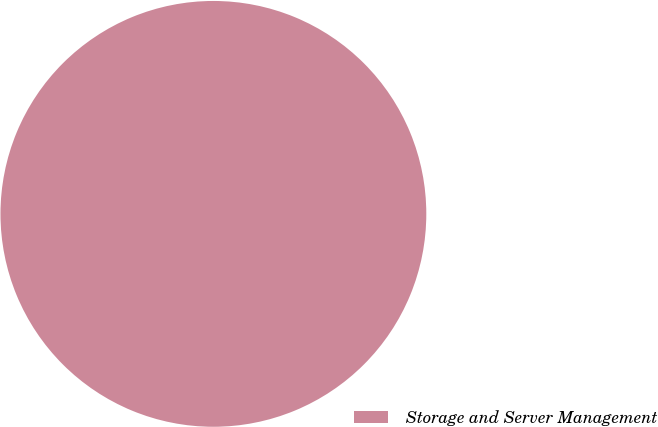Convert chart to OTSL. <chart><loc_0><loc_0><loc_500><loc_500><pie_chart><fcel>Storage and Server Management<nl><fcel>100.0%<nl></chart> 